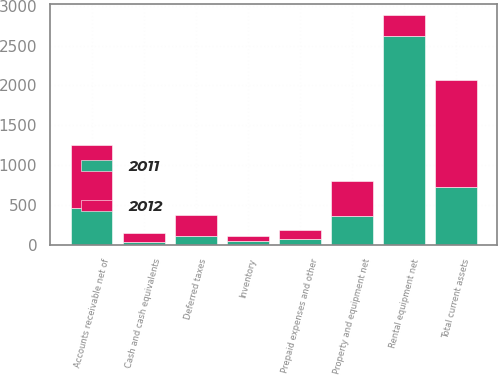Convert chart to OTSL. <chart><loc_0><loc_0><loc_500><loc_500><stacked_bar_chart><ecel><fcel>Cash and cash equivalents<fcel>Accounts receivable net of<fcel>Inventory<fcel>Prepaid expenses and other<fcel>Deferred taxes<fcel>Total current assets<fcel>Rental equipment net<fcel>Property and equipment net<nl><fcel>2012<fcel>106<fcel>793<fcel>68<fcel>111<fcel>265<fcel>1343<fcel>265<fcel>428<nl><fcel>2011<fcel>36<fcel>464<fcel>44<fcel>75<fcel>104<fcel>723<fcel>2617<fcel>366<nl></chart> 